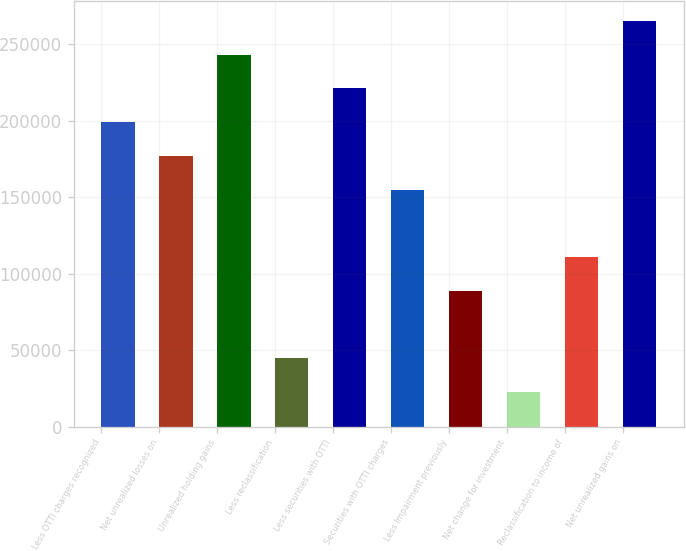Convert chart to OTSL. <chart><loc_0><loc_0><loc_500><loc_500><bar_chart><fcel>Less OTTI charges recognized<fcel>Net unrealized losses on<fcel>Unrealized holding gains<fcel>Less reclassification<fcel>Less securities with OTTI<fcel>Securities with OTTI charges<fcel>Less Impairment previously<fcel>Net change for investment<fcel>Reclassification to income of<fcel>Net unrealized gains on<nl><fcel>199096<fcel>177024<fcel>243240<fcel>44592<fcel>221168<fcel>154952<fcel>88736<fcel>22520<fcel>110808<fcel>265312<nl></chart> 